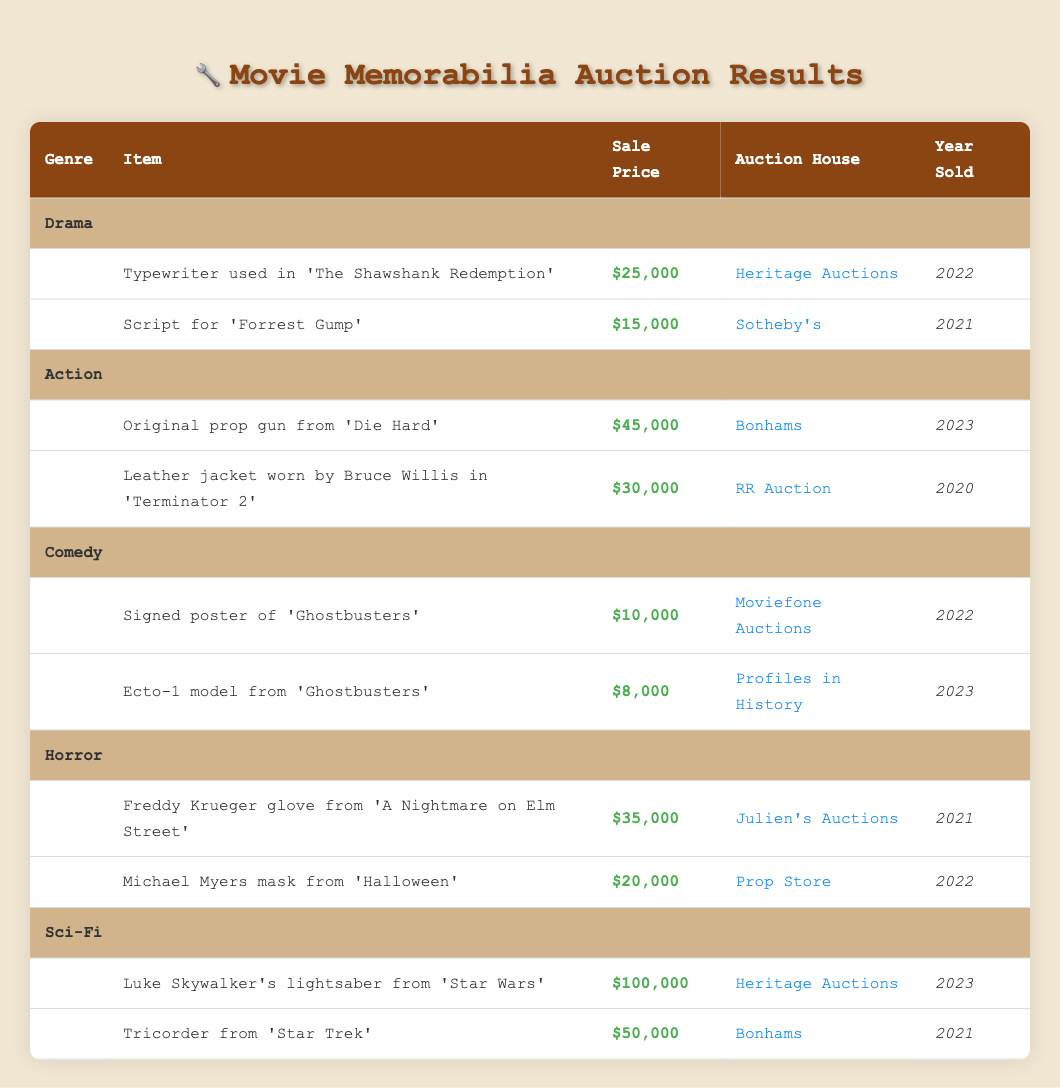What is the highest sale price for an item in the Sci-Fi genre? The highest sale price for an item in the Sci-Fi genre is $100,000, which is for Luke Skywalker's lightsaber from 'Star Wars'. This can be identified directly from the table under the Sci-Fi genre.
Answer: $100,000 Which auction house sold the prop gun from 'Die Hard'? The auction house that sold the prop gun from 'Die Hard' is Bonhams, as listed in the corresponding row for Action items.
Answer: Bonhams What is the total sale price of items sold in the Comedy genre? The total sale price for items in the Comedy genre can be calculated by adding the sale prices of both items: $10,000 (for the signed poster of 'Ghostbusters') and $8,000 (for the Ecto-1 model), which equals $18,000.
Answer: $18,000 Did any Horror memorabilia sell for more than $30,000? Yes, the Freddy Krueger glove from 'A Nightmare on Elm Street' sold for $35,000, which is above $30,000. This can be confirmed by looking at the sale prices listed under the Horror genre.
Answer: Yes What was the average sale price for items in the Action genre? To find the average sale price in the Action genre, sum the sale prices of both items: $45,000 (for the prop gun) and $30,000 (for the leather jacket), giving a total of $75,000. There are 2 items, so the average is $75,000 / 2 = $37,500.
Answer: $37,500 Which item from the Horror genre had the lowest sale price? The item with the lowest sale price in the Horror genre is the Michael Myers mask from 'Halloween', with a sale price of $20,000. This can be determined by comparing the sale prices of both items listed under Horror.
Answer: Michael Myers mask from 'Halloween' What is the difference in sale prices between the highest and lowest items in the Sci-Fi genre? The highest item in Sci-Fi, Luke Skywalker’s lightsaber, sold for $100,000, while the lowest, the Tricorder from 'Star Trek', sold for $50,000. The difference is $100,000 - $50,000 = $50,000.
Answer: $50,000 How many items were sold at Sotheby's? According to the table, only one item from the Memorabilia Auction Results was sold at Sotheby's, which is the script for 'Forrest Gump'. This is clearly indicated in the table under the Drama genre.
Answer: 1 Which genre had the item with the highest sale price overall? The Sci-Fi genre had the item with the highest sale price overall, which is Luke Skywalker’s lightsaber sold for $100,000. This information can be extracted by comparing the highest sale prices across all genres.
Answer: Sci-Fi 